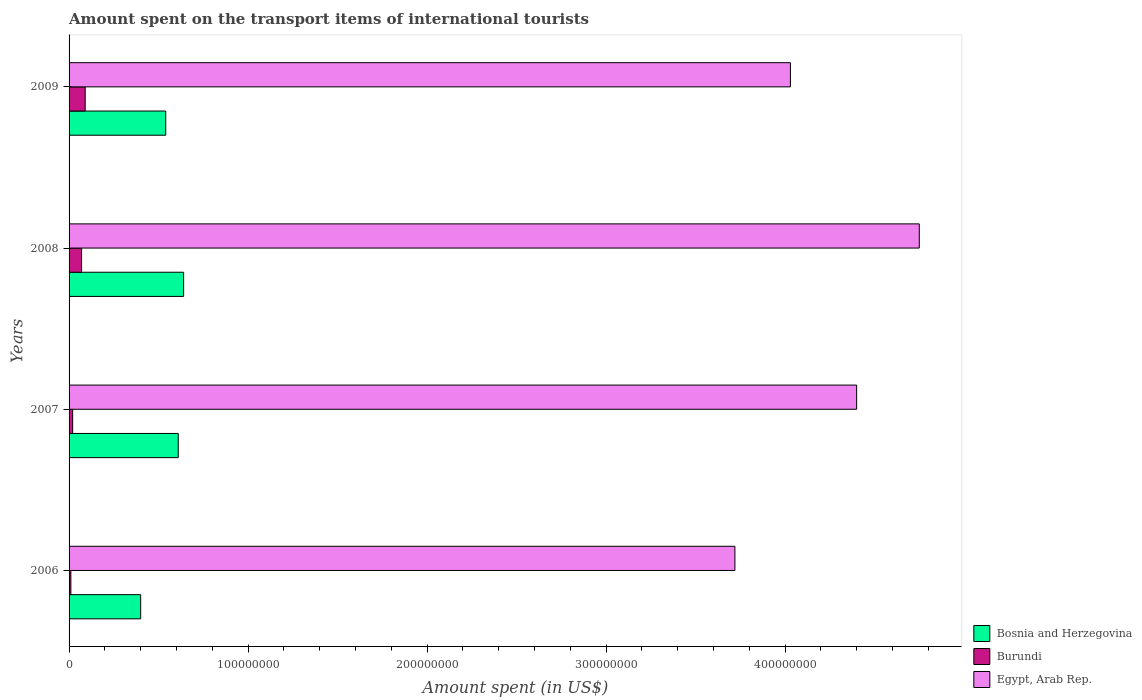How many groups of bars are there?
Offer a terse response. 4. Are the number of bars per tick equal to the number of legend labels?
Your answer should be very brief. Yes. Are the number of bars on each tick of the Y-axis equal?
Ensure brevity in your answer.  Yes. How many bars are there on the 1st tick from the top?
Give a very brief answer. 3. How many bars are there on the 3rd tick from the bottom?
Ensure brevity in your answer.  3. What is the label of the 3rd group of bars from the top?
Give a very brief answer. 2007. What is the amount spent on the transport items of international tourists in Bosnia and Herzegovina in 2008?
Keep it short and to the point. 6.40e+07. Across all years, what is the maximum amount spent on the transport items of international tourists in Egypt, Arab Rep.?
Your answer should be very brief. 4.75e+08. Across all years, what is the minimum amount spent on the transport items of international tourists in Egypt, Arab Rep.?
Offer a very short reply. 3.72e+08. What is the total amount spent on the transport items of international tourists in Egypt, Arab Rep. in the graph?
Your response must be concise. 1.69e+09. What is the difference between the amount spent on the transport items of international tourists in Bosnia and Herzegovina in 2006 and that in 2008?
Your answer should be very brief. -2.40e+07. What is the difference between the amount spent on the transport items of international tourists in Bosnia and Herzegovina in 2009 and the amount spent on the transport items of international tourists in Egypt, Arab Rep. in 2008?
Offer a terse response. -4.21e+08. What is the average amount spent on the transport items of international tourists in Egypt, Arab Rep. per year?
Your answer should be compact. 4.22e+08. In the year 2008, what is the difference between the amount spent on the transport items of international tourists in Egypt, Arab Rep. and amount spent on the transport items of international tourists in Bosnia and Herzegovina?
Your response must be concise. 4.11e+08. What is the ratio of the amount spent on the transport items of international tourists in Egypt, Arab Rep. in 2007 to that in 2008?
Your answer should be very brief. 0.93. Is the amount spent on the transport items of international tourists in Egypt, Arab Rep. in 2006 less than that in 2008?
Make the answer very short. Yes. What is the difference between the highest and the second highest amount spent on the transport items of international tourists in Burundi?
Make the answer very short. 2.00e+06. What is the difference between the highest and the lowest amount spent on the transport items of international tourists in Bosnia and Herzegovina?
Give a very brief answer. 2.40e+07. In how many years, is the amount spent on the transport items of international tourists in Burundi greater than the average amount spent on the transport items of international tourists in Burundi taken over all years?
Ensure brevity in your answer.  2. What does the 3rd bar from the top in 2007 represents?
Provide a succinct answer. Bosnia and Herzegovina. What does the 1st bar from the bottom in 2006 represents?
Keep it short and to the point. Bosnia and Herzegovina. Is it the case that in every year, the sum of the amount spent on the transport items of international tourists in Bosnia and Herzegovina and amount spent on the transport items of international tourists in Burundi is greater than the amount spent on the transport items of international tourists in Egypt, Arab Rep.?
Give a very brief answer. No. Are all the bars in the graph horizontal?
Provide a short and direct response. Yes. How many years are there in the graph?
Offer a very short reply. 4. What is the difference between two consecutive major ticks on the X-axis?
Offer a very short reply. 1.00e+08. Are the values on the major ticks of X-axis written in scientific E-notation?
Keep it short and to the point. No. Where does the legend appear in the graph?
Make the answer very short. Bottom right. What is the title of the graph?
Your response must be concise. Amount spent on the transport items of international tourists. Does "Austria" appear as one of the legend labels in the graph?
Provide a succinct answer. No. What is the label or title of the X-axis?
Give a very brief answer. Amount spent (in US$). What is the Amount spent (in US$) of Bosnia and Herzegovina in 2006?
Offer a very short reply. 4.00e+07. What is the Amount spent (in US$) in Egypt, Arab Rep. in 2006?
Give a very brief answer. 3.72e+08. What is the Amount spent (in US$) in Bosnia and Herzegovina in 2007?
Keep it short and to the point. 6.10e+07. What is the Amount spent (in US$) of Egypt, Arab Rep. in 2007?
Keep it short and to the point. 4.40e+08. What is the Amount spent (in US$) in Bosnia and Herzegovina in 2008?
Offer a very short reply. 6.40e+07. What is the Amount spent (in US$) in Egypt, Arab Rep. in 2008?
Your answer should be compact. 4.75e+08. What is the Amount spent (in US$) in Bosnia and Herzegovina in 2009?
Give a very brief answer. 5.40e+07. What is the Amount spent (in US$) in Burundi in 2009?
Make the answer very short. 9.00e+06. What is the Amount spent (in US$) of Egypt, Arab Rep. in 2009?
Ensure brevity in your answer.  4.03e+08. Across all years, what is the maximum Amount spent (in US$) in Bosnia and Herzegovina?
Provide a succinct answer. 6.40e+07. Across all years, what is the maximum Amount spent (in US$) in Burundi?
Your answer should be very brief. 9.00e+06. Across all years, what is the maximum Amount spent (in US$) in Egypt, Arab Rep.?
Keep it short and to the point. 4.75e+08. Across all years, what is the minimum Amount spent (in US$) of Bosnia and Herzegovina?
Offer a terse response. 4.00e+07. Across all years, what is the minimum Amount spent (in US$) of Egypt, Arab Rep.?
Offer a very short reply. 3.72e+08. What is the total Amount spent (in US$) in Bosnia and Herzegovina in the graph?
Make the answer very short. 2.19e+08. What is the total Amount spent (in US$) in Burundi in the graph?
Provide a short and direct response. 1.90e+07. What is the total Amount spent (in US$) in Egypt, Arab Rep. in the graph?
Provide a short and direct response. 1.69e+09. What is the difference between the Amount spent (in US$) in Bosnia and Herzegovina in 2006 and that in 2007?
Offer a very short reply. -2.10e+07. What is the difference between the Amount spent (in US$) of Egypt, Arab Rep. in 2006 and that in 2007?
Ensure brevity in your answer.  -6.80e+07. What is the difference between the Amount spent (in US$) of Bosnia and Herzegovina in 2006 and that in 2008?
Keep it short and to the point. -2.40e+07. What is the difference between the Amount spent (in US$) of Burundi in 2006 and that in 2008?
Ensure brevity in your answer.  -6.00e+06. What is the difference between the Amount spent (in US$) of Egypt, Arab Rep. in 2006 and that in 2008?
Provide a succinct answer. -1.03e+08. What is the difference between the Amount spent (in US$) of Bosnia and Herzegovina in 2006 and that in 2009?
Your answer should be compact. -1.40e+07. What is the difference between the Amount spent (in US$) in Burundi in 2006 and that in 2009?
Make the answer very short. -8.00e+06. What is the difference between the Amount spent (in US$) in Egypt, Arab Rep. in 2006 and that in 2009?
Provide a succinct answer. -3.10e+07. What is the difference between the Amount spent (in US$) in Burundi in 2007 and that in 2008?
Keep it short and to the point. -5.00e+06. What is the difference between the Amount spent (in US$) in Egypt, Arab Rep. in 2007 and that in 2008?
Make the answer very short. -3.50e+07. What is the difference between the Amount spent (in US$) in Burundi in 2007 and that in 2009?
Your answer should be very brief. -7.00e+06. What is the difference between the Amount spent (in US$) of Egypt, Arab Rep. in 2007 and that in 2009?
Provide a succinct answer. 3.70e+07. What is the difference between the Amount spent (in US$) in Burundi in 2008 and that in 2009?
Your answer should be very brief. -2.00e+06. What is the difference between the Amount spent (in US$) in Egypt, Arab Rep. in 2008 and that in 2009?
Make the answer very short. 7.20e+07. What is the difference between the Amount spent (in US$) of Bosnia and Herzegovina in 2006 and the Amount spent (in US$) of Burundi in 2007?
Ensure brevity in your answer.  3.80e+07. What is the difference between the Amount spent (in US$) in Bosnia and Herzegovina in 2006 and the Amount spent (in US$) in Egypt, Arab Rep. in 2007?
Your response must be concise. -4.00e+08. What is the difference between the Amount spent (in US$) of Burundi in 2006 and the Amount spent (in US$) of Egypt, Arab Rep. in 2007?
Keep it short and to the point. -4.39e+08. What is the difference between the Amount spent (in US$) of Bosnia and Herzegovina in 2006 and the Amount spent (in US$) of Burundi in 2008?
Your answer should be compact. 3.30e+07. What is the difference between the Amount spent (in US$) in Bosnia and Herzegovina in 2006 and the Amount spent (in US$) in Egypt, Arab Rep. in 2008?
Provide a short and direct response. -4.35e+08. What is the difference between the Amount spent (in US$) of Burundi in 2006 and the Amount spent (in US$) of Egypt, Arab Rep. in 2008?
Give a very brief answer. -4.74e+08. What is the difference between the Amount spent (in US$) of Bosnia and Herzegovina in 2006 and the Amount spent (in US$) of Burundi in 2009?
Offer a terse response. 3.10e+07. What is the difference between the Amount spent (in US$) of Bosnia and Herzegovina in 2006 and the Amount spent (in US$) of Egypt, Arab Rep. in 2009?
Make the answer very short. -3.63e+08. What is the difference between the Amount spent (in US$) of Burundi in 2006 and the Amount spent (in US$) of Egypt, Arab Rep. in 2009?
Provide a succinct answer. -4.02e+08. What is the difference between the Amount spent (in US$) in Bosnia and Herzegovina in 2007 and the Amount spent (in US$) in Burundi in 2008?
Provide a succinct answer. 5.40e+07. What is the difference between the Amount spent (in US$) in Bosnia and Herzegovina in 2007 and the Amount spent (in US$) in Egypt, Arab Rep. in 2008?
Your response must be concise. -4.14e+08. What is the difference between the Amount spent (in US$) of Burundi in 2007 and the Amount spent (in US$) of Egypt, Arab Rep. in 2008?
Provide a succinct answer. -4.73e+08. What is the difference between the Amount spent (in US$) of Bosnia and Herzegovina in 2007 and the Amount spent (in US$) of Burundi in 2009?
Your answer should be compact. 5.20e+07. What is the difference between the Amount spent (in US$) in Bosnia and Herzegovina in 2007 and the Amount spent (in US$) in Egypt, Arab Rep. in 2009?
Your answer should be very brief. -3.42e+08. What is the difference between the Amount spent (in US$) of Burundi in 2007 and the Amount spent (in US$) of Egypt, Arab Rep. in 2009?
Provide a short and direct response. -4.01e+08. What is the difference between the Amount spent (in US$) in Bosnia and Herzegovina in 2008 and the Amount spent (in US$) in Burundi in 2009?
Keep it short and to the point. 5.50e+07. What is the difference between the Amount spent (in US$) of Bosnia and Herzegovina in 2008 and the Amount spent (in US$) of Egypt, Arab Rep. in 2009?
Your answer should be very brief. -3.39e+08. What is the difference between the Amount spent (in US$) of Burundi in 2008 and the Amount spent (in US$) of Egypt, Arab Rep. in 2009?
Keep it short and to the point. -3.96e+08. What is the average Amount spent (in US$) in Bosnia and Herzegovina per year?
Keep it short and to the point. 5.48e+07. What is the average Amount spent (in US$) in Burundi per year?
Provide a succinct answer. 4.75e+06. What is the average Amount spent (in US$) of Egypt, Arab Rep. per year?
Offer a very short reply. 4.22e+08. In the year 2006, what is the difference between the Amount spent (in US$) of Bosnia and Herzegovina and Amount spent (in US$) of Burundi?
Your answer should be very brief. 3.90e+07. In the year 2006, what is the difference between the Amount spent (in US$) in Bosnia and Herzegovina and Amount spent (in US$) in Egypt, Arab Rep.?
Give a very brief answer. -3.32e+08. In the year 2006, what is the difference between the Amount spent (in US$) in Burundi and Amount spent (in US$) in Egypt, Arab Rep.?
Make the answer very short. -3.71e+08. In the year 2007, what is the difference between the Amount spent (in US$) of Bosnia and Herzegovina and Amount spent (in US$) of Burundi?
Make the answer very short. 5.90e+07. In the year 2007, what is the difference between the Amount spent (in US$) in Bosnia and Herzegovina and Amount spent (in US$) in Egypt, Arab Rep.?
Ensure brevity in your answer.  -3.79e+08. In the year 2007, what is the difference between the Amount spent (in US$) of Burundi and Amount spent (in US$) of Egypt, Arab Rep.?
Your answer should be very brief. -4.38e+08. In the year 2008, what is the difference between the Amount spent (in US$) in Bosnia and Herzegovina and Amount spent (in US$) in Burundi?
Your response must be concise. 5.70e+07. In the year 2008, what is the difference between the Amount spent (in US$) in Bosnia and Herzegovina and Amount spent (in US$) in Egypt, Arab Rep.?
Offer a very short reply. -4.11e+08. In the year 2008, what is the difference between the Amount spent (in US$) of Burundi and Amount spent (in US$) of Egypt, Arab Rep.?
Offer a terse response. -4.68e+08. In the year 2009, what is the difference between the Amount spent (in US$) in Bosnia and Herzegovina and Amount spent (in US$) in Burundi?
Offer a very short reply. 4.50e+07. In the year 2009, what is the difference between the Amount spent (in US$) of Bosnia and Herzegovina and Amount spent (in US$) of Egypt, Arab Rep.?
Offer a terse response. -3.49e+08. In the year 2009, what is the difference between the Amount spent (in US$) in Burundi and Amount spent (in US$) in Egypt, Arab Rep.?
Your answer should be very brief. -3.94e+08. What is the ratio of the Amount spent (in US$) in Bosnia and Herzegovina in 2006 to that in 2007?
Ensure brevity in your answer.  0.66. What is the ratio of the Amount spent (in US$) of Burundi in 2006 to that in 2007?
Your response must be concise. 0.5. What is the ratio of the Amount spent (in US$) of Egypt, Arab Rep. in 2006 to that in 2007?
Ensure brevity in your answer.  0.85. What is the ratio of the Amount spent (in US$) in Bosnia and Herzegovina in 2006 to that in 2008?
Your answer should be compact. 0.62. What is the ratio of the Amount spent (in US$) of Burundi in 2006 to that in 2008?
Provide a succinct answer. 0.14. What is the ratio of the Amount spent (in US$) of Egypt, Arab Rep. in 2006 to that in 2008?
Offer a very short reply. 0.78. What is the ratio of the Amount spent (in US$) in Bosnia and Herzegovina in 2006 to that in 2009?
Provide a short and direct response. 0.74. What is the ratio of the Amount spent (in US$) of Burundi in 2006 to that in 2009?
Your answer should be compact. 0.11. What is the ratio of the Amount spent (in US$) of Bosnia and Herzegovina in 2007 to that in 2008?
Make the answer very short. 0.95. What is the ratio of the Amount spent (in US$) of Burundi in 2007 to that in 2008?
Your response must be concise. 0.29. What is the ratio of the Amount spent (in US$) of Egypt, Arab Rep. in 2007 to that in 2008?
Ensure brevity in your answer.  0.93. What is the ratio of the Amount spent (in US$) in Bosnia and Herzegovina in 2007 to that in 2009?
Your answer should be compact. 1.13. What is the ratio of the Amount spent (in US$) in Burundi in 2007 to that in 2009?
Provide a short and direct response. 0.22. What is the ratio of the Amount spent (in US$) of Egypt, Arab Rep. in 2007 to that in 2009?
Give a very brief answer. 1.09. What is the ratio of the Amount spent (in US$) in Bosnia and Herzegovina in 2008 to that in 2009?
Make the answer very short. 1.19. What is the ratio of the Amount spent (in US$) in Burundi in 2008 to that in 2009?
Your answer should be very brief. 0.78. What is the ratio of the Amount spent (in US$) in Egypt, Arab Rep. in 2008 to that in 2009?
Keep it short and to the point. 1.18. What is the difference between the highest and the second highest Amount spent (in US$) of Bosnia and Herzegovina?
Provide a succinct answer. 3.00e+06. What is the difference between the highest and the second highest Amount spent (in US$) of Egypt, Arab Rep.?
Offer a terse response. 3.50e+07. What is the difference between the highest and the lowest Amount spent (in US$) of Bosnia and Herzegovina?
Offer a terse response. 2.40e+07. What is the difference between the highest and the lowest Amount spent (in US$) of Burundi?
Your answer should be very brief. 8.00e+06. What is the difference between the highest and the lowest Amount spent (in US$) in Egypt, Arab Rep.?
Offer a terse response. 1.03e+08. 